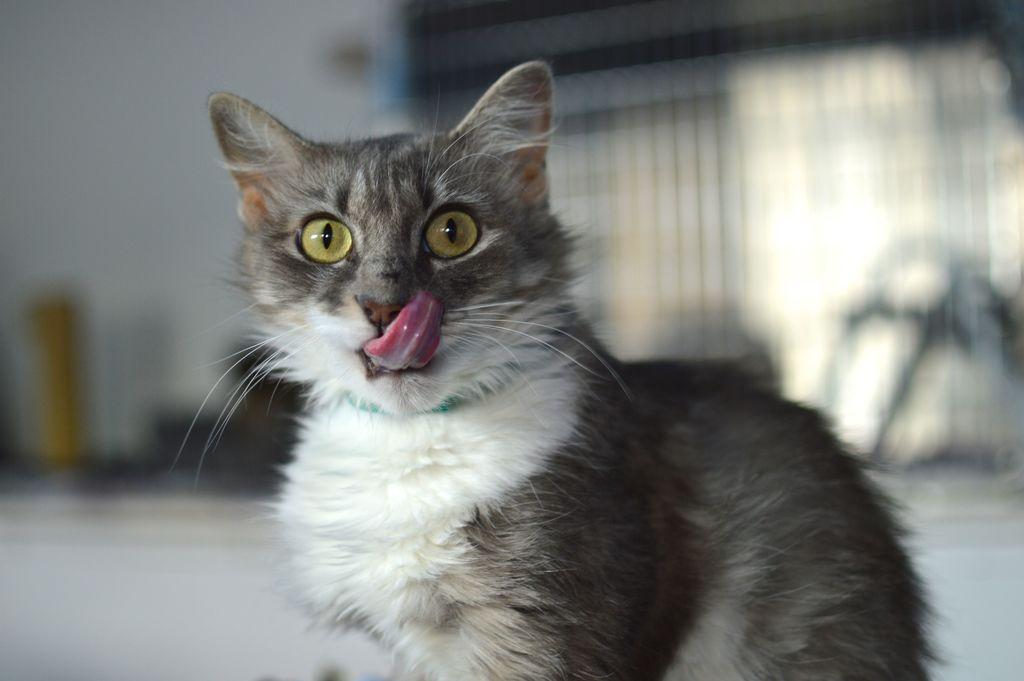Could you give a brief overview of what you see in this image? In the center of the image we can see a cat is sitting. In the background of the image we can see the wall, glass door and some other objects. At the bottom of the image we can see the floor. 